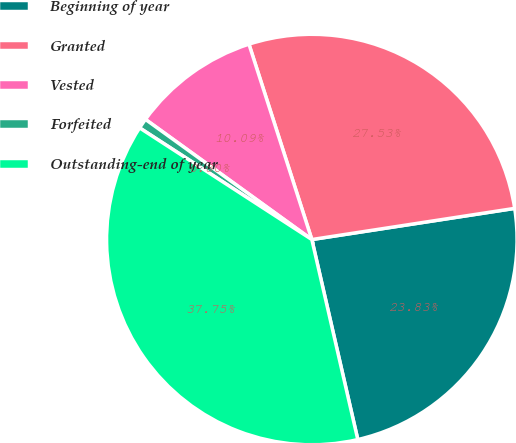Convert chart to OTSL. <chart><loc_0><loc_0><loc_500><loc_500><pie_chart><fcel>Beginning of year<fcel>Granted<fcel>Vested<fcel>Forfeited<fcel>Outstanding-end of year<nl><fcel>23.83%<fcel>27.53%<fcel>10.09%<fcel>0.8%<fcel>37.75%<nl></chart> 